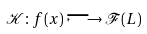<formula> <loc_0><loc_0><loc_500><loc_500>\mathcal { K } \colon f ( x ) \longmapsto \mathcal { F } ( L )</formula> 